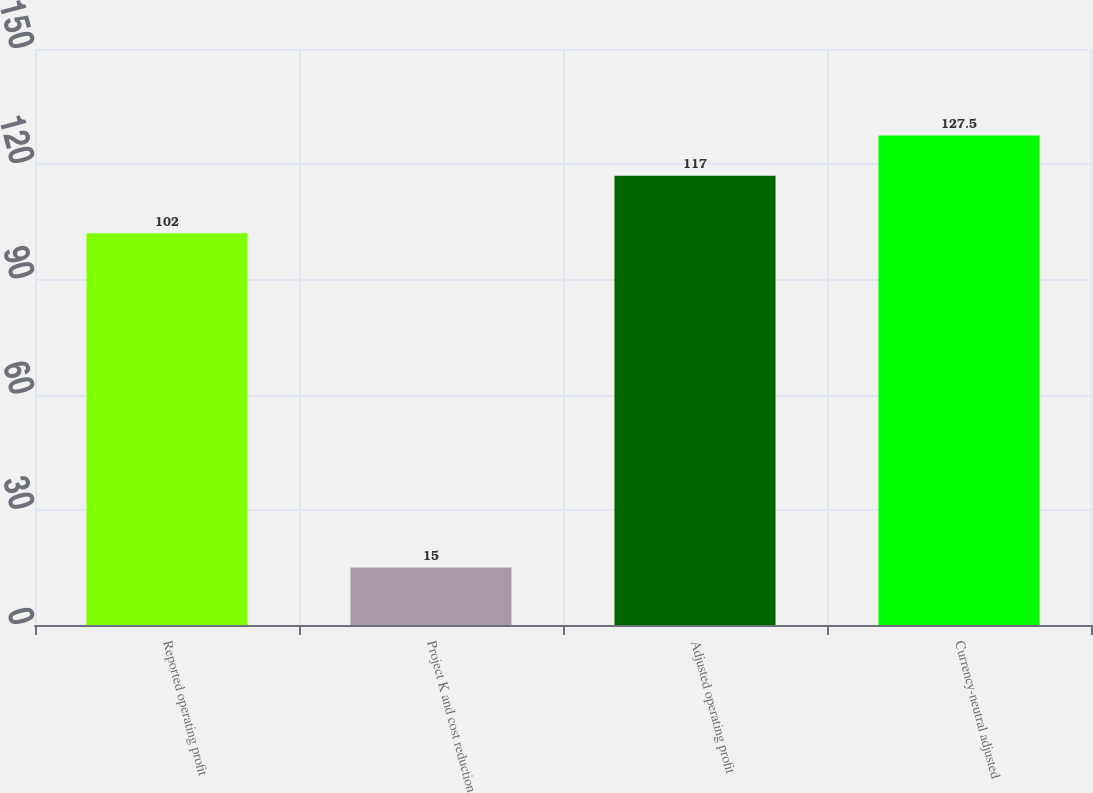<chart> <loc_0><loc_0><loc_500><loc_500><bar_chart><fcel>Reported operating profit<fcel>Project K and cost reduction<fcel>Adjusted operating profit<fcel>Currency-neutral adjusted<nl><fcel>102<fcel>15<fcel>117<fcel>127.5<nl></chart> 